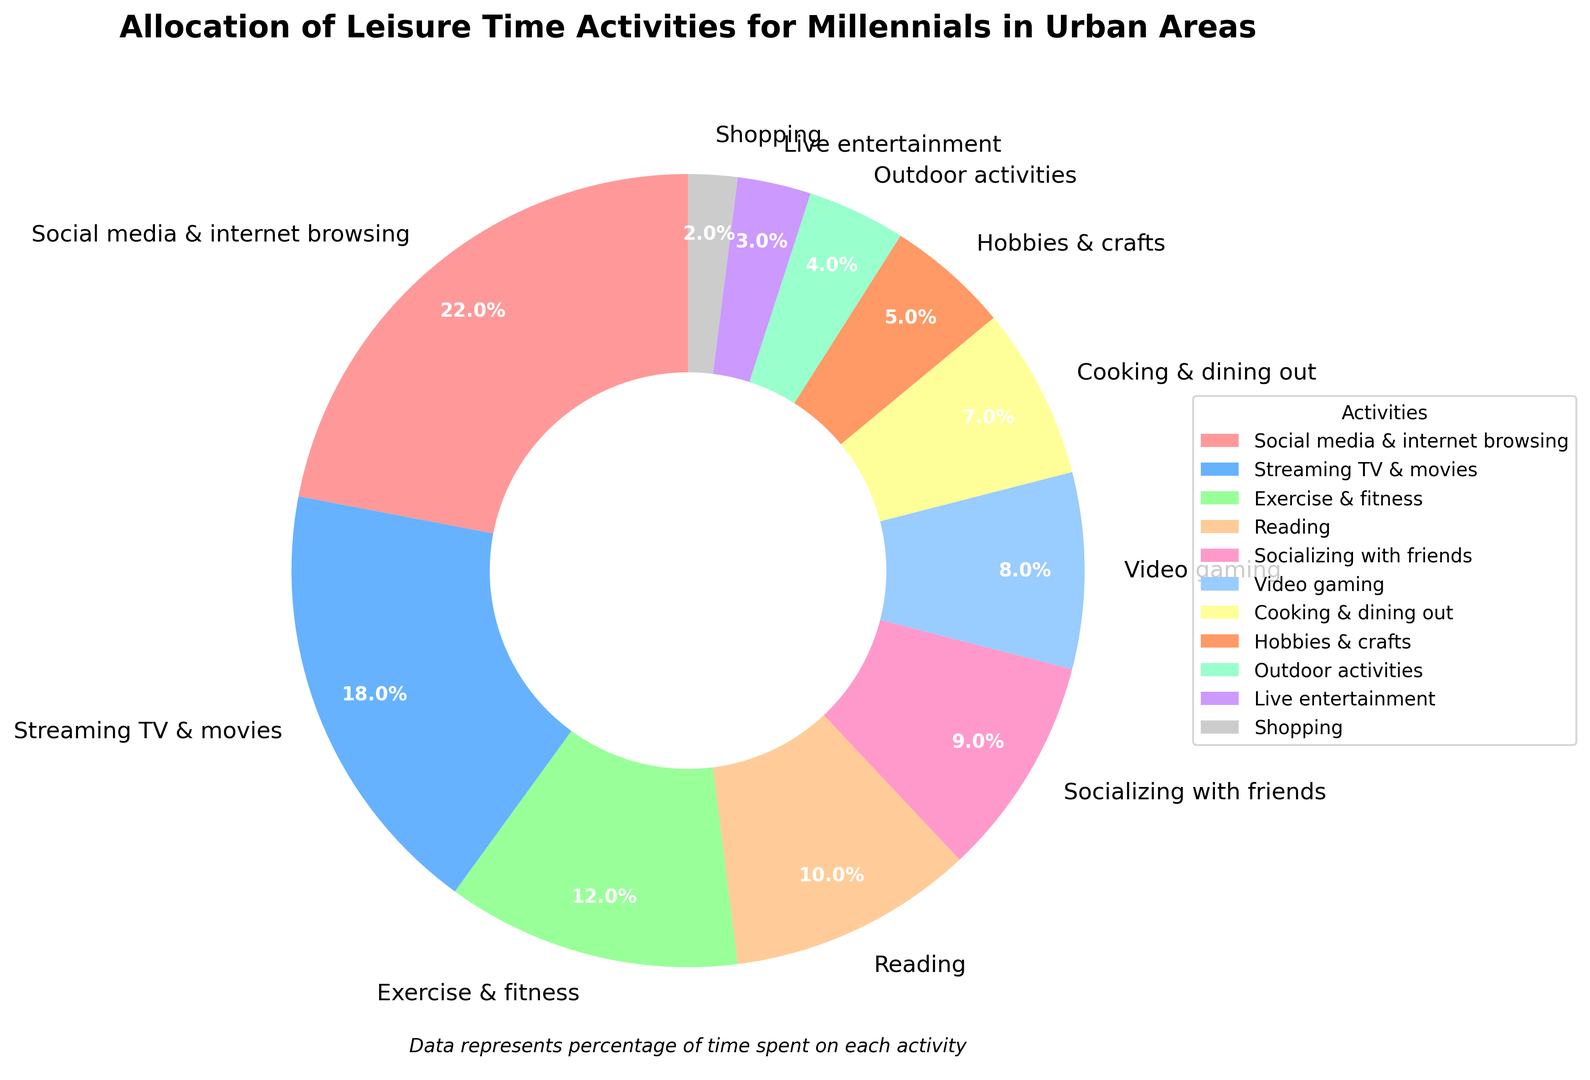What's the most common leisure activity for millennials in urban areas? By examining the pie chart, we see that the largest wedge represents "Social media & internet browsing" with 22%. This segment's size is visually the largest, indicating it's the most common activity.
Answer: Social media & internet browsing Which two activities are equally represented in the pie chart? The pie chart shows that "Hobbies & crafts" and "Outdoor activities" both have equal-sized segments, each representing 5% and 4% respectively.
Answer: Hobbies & crafts, Outdoor activities What percentage of leisure time is allocated to "Video gaming" and "Exercise & fitness" combined? To get the combined percentage, sum the percentages of "Video gaming" (8%) and "Exercise & fitness" (12%). So, 8% + 12% = 20%.
Answer: 20% Which activity is allocated twice as much time as "Cooking & dining out"? In the pie chart, "Streaming TV & movies" has 18% allocation, and "Cooking & dining out" has 7%. Since 18% is approximately twice as much as 7%, the answer is "Streaming TV & movies".
Answer: Streaming TV & movies How much more time do millennials spend on "Reading" compared to "Shopping"? The pie chart shows 10% for "Reading" and 2% for "Shopping". The difference is calculated by subtracting the percentage of "Shopping" from "Reading": 10% - 2% = 8%.
Answer: 8% What is the least popular leisure activity according to the pie chart? The smallest segment on the pie chart represents "Shopping", which has an allocation of 2%.
Answer: Shopping Compare the time spent on "Socializing with friends" and "Video gaming". Which is more and by how much? "Socializing with friends" is allocated 9% while "Video gaming" is allocated 8%. The difference is 9% - 8% = 1%. Therefore, millennials spend 1% more time on "Socializing with friends" compared to "Video gaming".
Answer: Socializing with friends by 1% What activities combined account for just under half of the leisure time? Reviewing the chart, "Social media & internet browsing" (22%) and "Streaming TV & movies" (18%) together account for 40%. The next largest activity, "Exercise & fitness" (12%) when added would put the total to 52%, which is over half, so the combination of the first two is just under half.
Answer: Social media & internet browsing, Streaming TV & movies Which color represents the segment for "Live entertainment"? By examining the pie chart, "Live entertainment" is represented by a purple segment, which stands out visually among the other colors.
Answer: Purple 